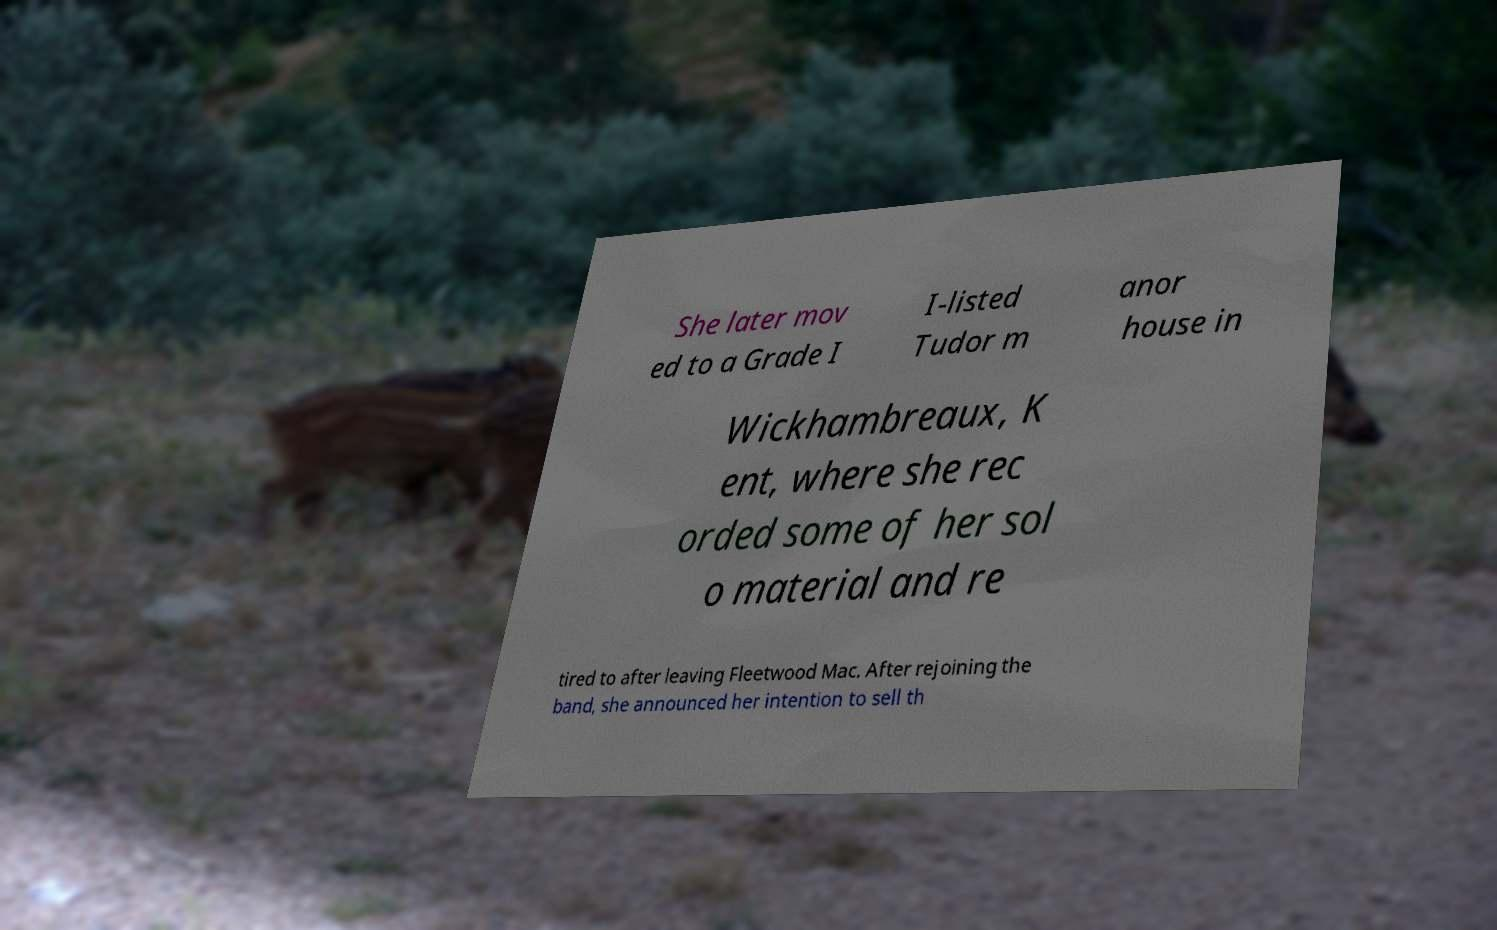Could you extract and type out the text from this image? She later mov ed to a Grade I I-listed Tudor m anor house in Wickhambreaux, K ent, where she rec orded some of her sol o material and re tired to after leaving Fleetwood Mac. After rejoining the band, she announced her intention to sell th 